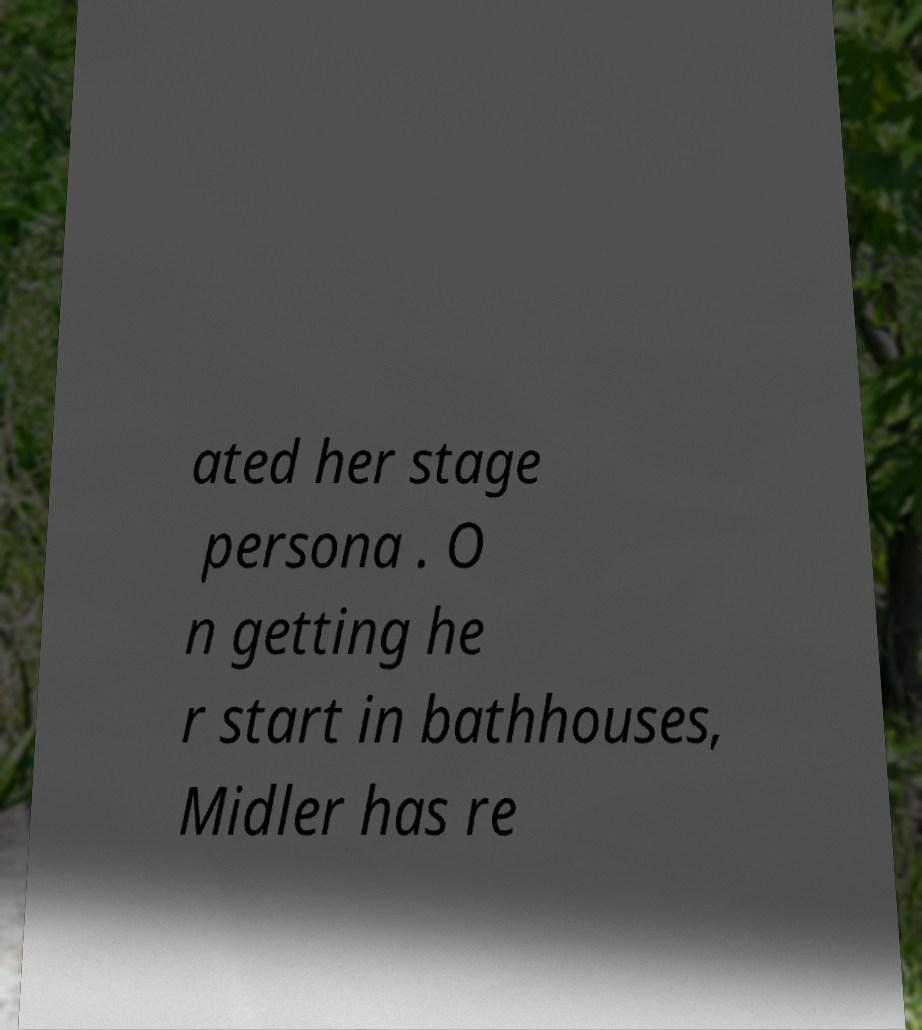Can you accurately transcribe the text from the provided image for me? ated her stage persona . O n getting he r start in bathhouses, Midler has re 